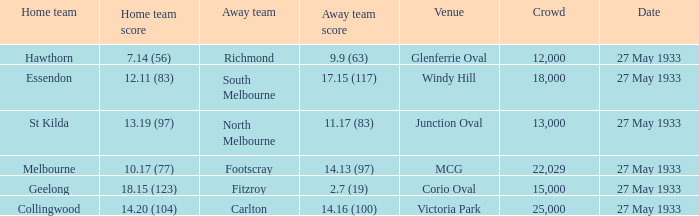In the match where the home team scored 14.20 (104), how many attendees were in the crowd? 25000.0. 